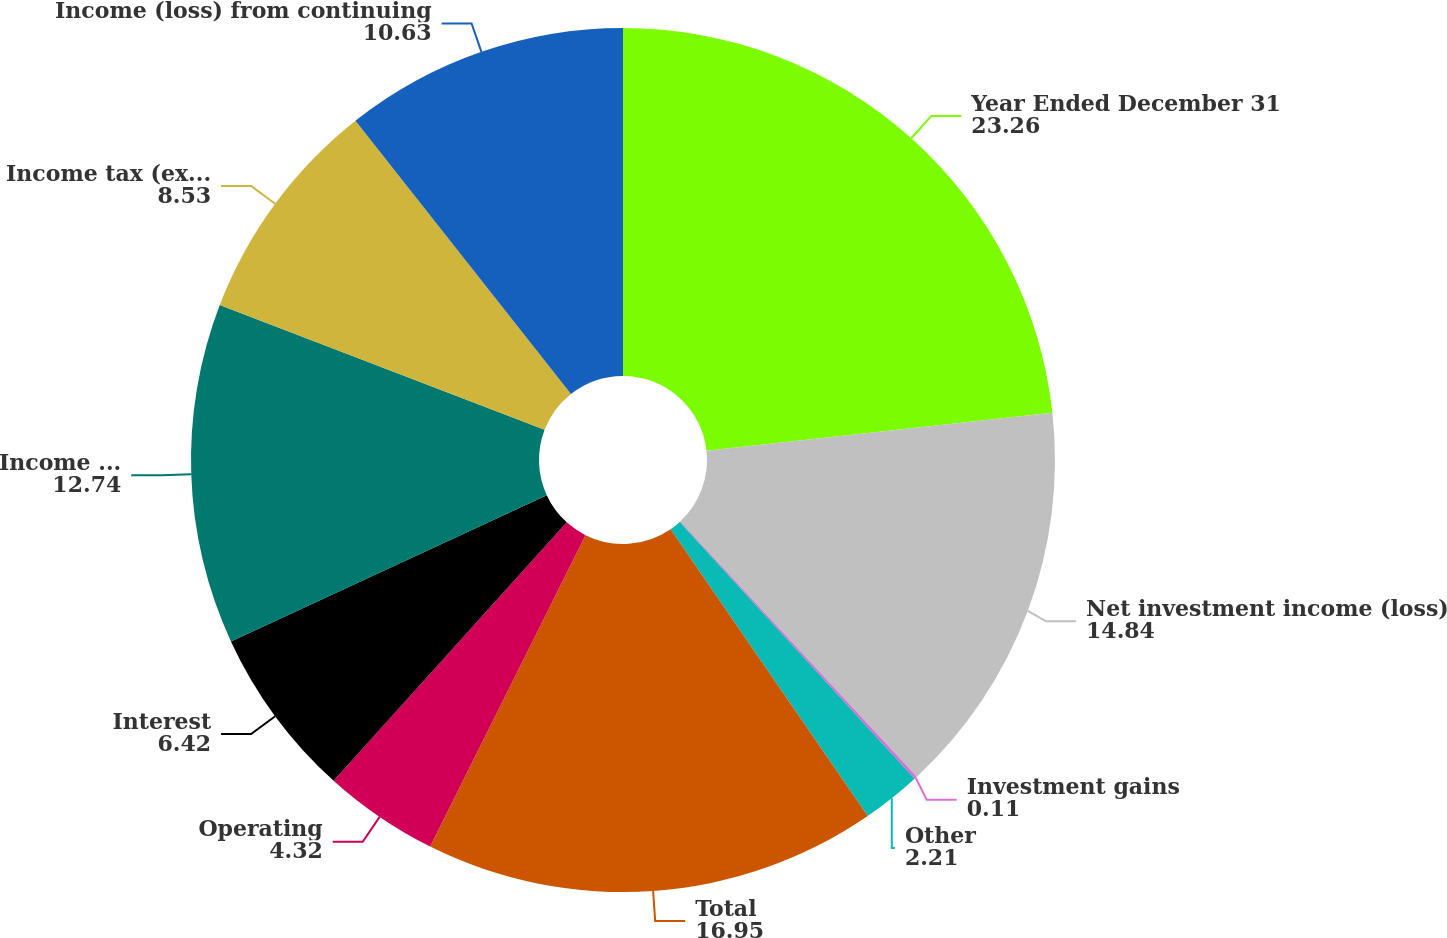Convert chart. <chart><loc_0><loc_0><loc_500><loc_500><pie_chart><fcel>Year Ended December 31<fcel>Net investment income (loss)<fcel>Investment gains<fcel>Other<fcel>Total<fcel>Operating<fcel>Interest<fcel>Income (loss) before income<fcel>Income tax (expense) benefit<fcel>Income (loss) from continuing<nl><fcel>23.26%<fcel>14.84%<fcel>0.11%<fcel>2.21%<fcel>16.95%<fcel>4.32%<fcel>6.42%<fcel>12.74%<fcel>8.53%<fcel>10.63%<nl></chart> 